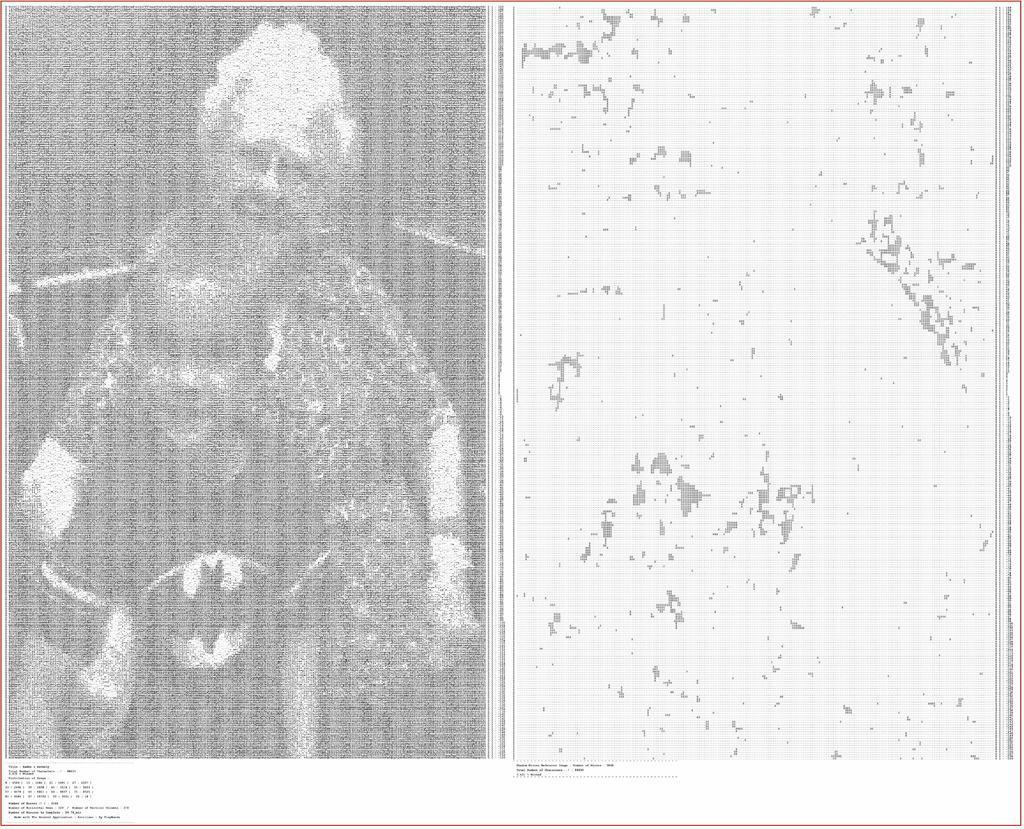How would you summarize this image in a sentence or two? This is a collage image. This is a black and white image. On the left side of the image we can see two people. On the right side of the image we can see white surface. At the bottom of the image we can see the text. 